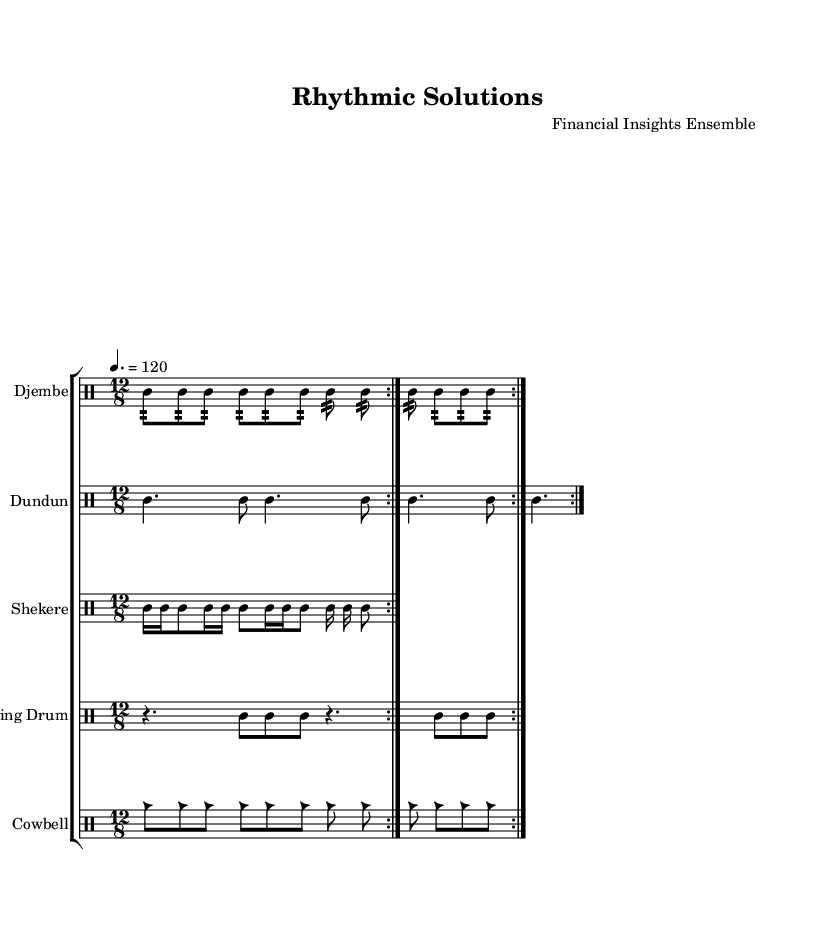What key is this piece in? The key signature indicated is C major, which is specified in the global section of the code.
Answer: C major What is the time signature of this piece? The time signature shown is 12/8, which can be found in the global settings of the music code.
Answer: 12/8 What is the tempo marking for this music? The tempo is marked at 4. = 120, indicating a quarter note equals 120 beats per minute. This is clearly stated in the global section.
Answer: 120 How many different percussion instruments are in this ensemble? The music features five distinct percussion instruments: Djembe, Dundun, Shekere, Talking Drum, and Cowbell, as listed in the staff group of the score.
Answer: 5 What rhythmic pattern does the Djembe play? The Djembe plays a repeated pattern of eight 32nd notes followed by more sets of the same, as outlined in its specific drummode section.
Answer: Eight 32nd notes How many beats does the Dundun's rhythmic pattern contain? The Dundun’s pattern consists of four dotted quarter notes and four eighth notes in total, repeated twice, resulting in a total of 16 beats (4 x 2) in each section.
Answer: 16 beats What is a distinctive characteristic of the Shekere's rhythm? The Shekere plays a pattern that includes sixteenth notes and eighth notes, showcasing a driving and syncopated characteristic typical of polyrhythms, as depicted in its drummode section.
Answer: Syncopated rhythm 